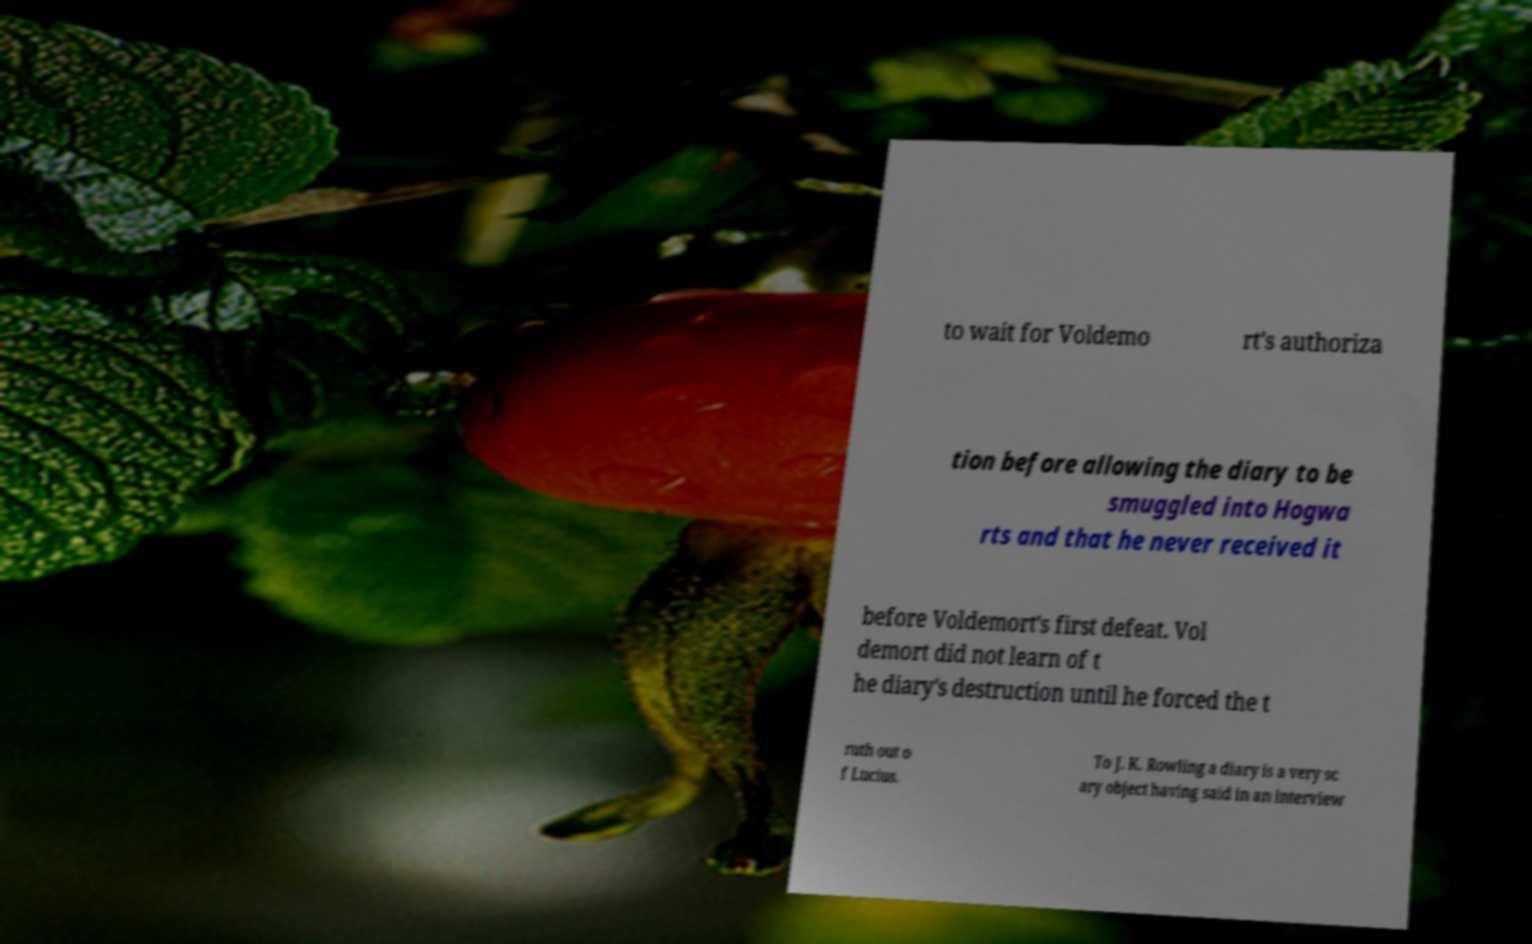Please read and relay the text visible in this image. What does it say? to wait for Voldemo rt's authoriza tion before allowing the diary to be smuggled into Hogwa rts and that he never received it before Voldemort's first defeat. Vol demort did not learn of t he diary's destruction until he forced the t ruth out o f Lucius. To J. K. Rowling a diary is a very sc ary object having said in an interview 